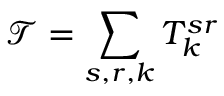Convert formula to latex. <formula><loc_0><loc_0><loc_500><loc_500>\mathcal { T } = \sum _ { s , r , k } T _ { k } ^ { s r }</formula> 